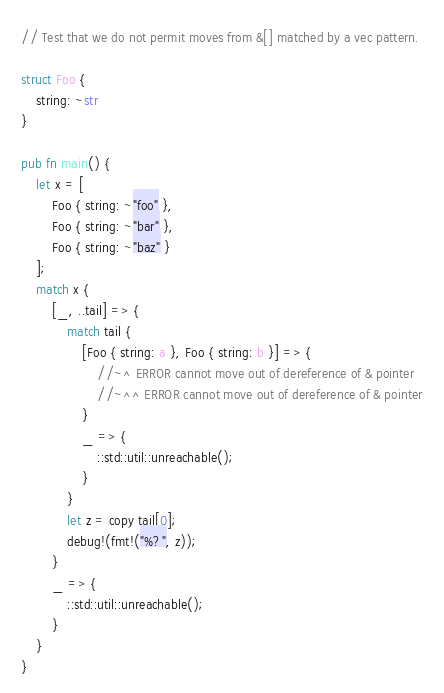Convert code to text. <code><loc_0><loc_0><loc_500><loc_500><_Rust_>// Test that we do not permit moves from &[] matched by a vec pattern.

struct Foo {
    string: ~str
}

pub fn main() {
    let x = [
        Foo { string: ~"foo" },
        Foo { string: ~"bar" },
        Foo { string: ~"baz" }
    ];
    match x {
        [_, ..tail] => {
            match tail {
                [Foo { string: a }, Foo { string: b }] => {
                    //~^ ERROR cannot move out of dereference of & pointer
                    //~^^ ERROR cannot move out of dereference of & pointer
                }
                _ => {
                    ::std::util::unreachable();
                }
            }
            let z = copy tail[0];
            debug!(fmt!("%?", z));
        }
        _ => {
            ::std::util::unreachable();
        }
    }
}
</code> 